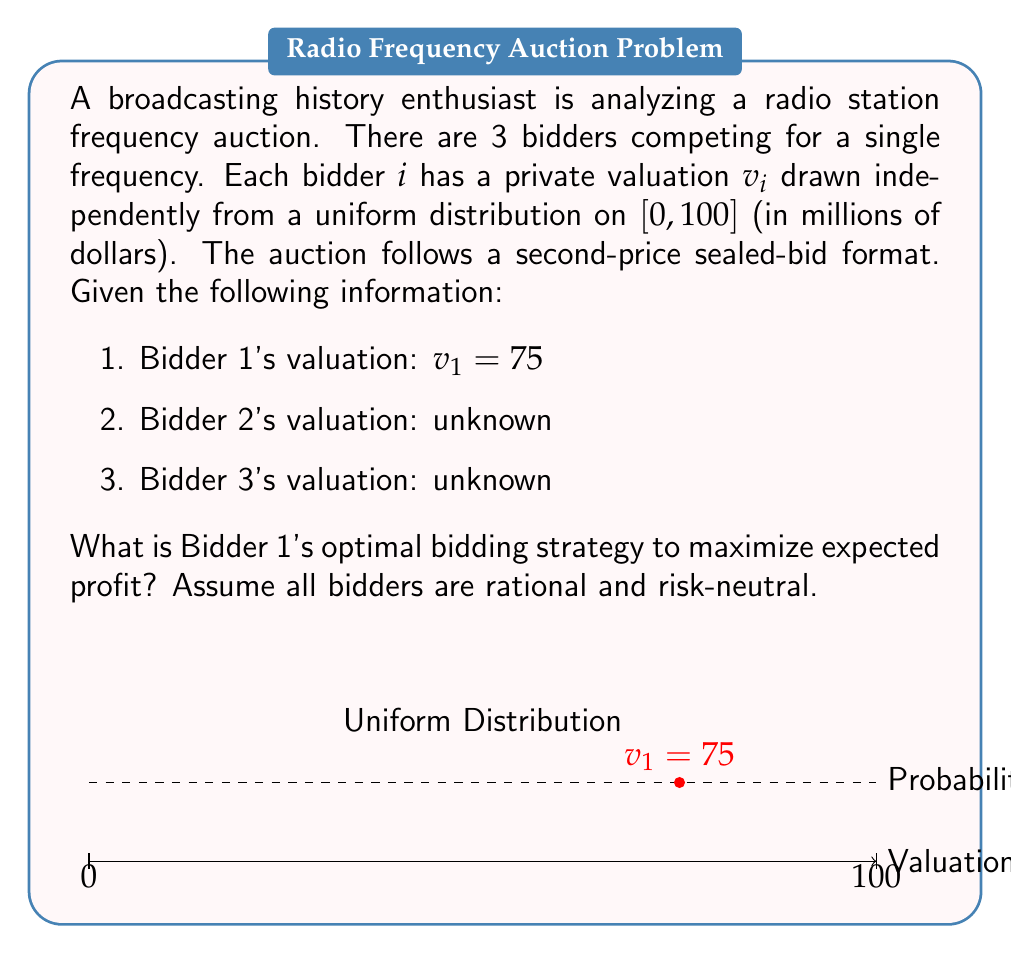Give your solution to this math problem. To solve this problem, we'll follow these steps:

1) In a second-price sealed-bid auction, the dominant strategy is to bid one's true valuation. This is because:

   a) Bidding above $v_1$ could result in winning but paying more than the valuation.
   b) Bidding below $v_1$ could result in losing when winning would have been profitable.

2) The optimal strategy is independent of other bidders' valuations or strategies.

3) Mathematically, we can prove this:

   Let $b_1$ be Bidder 1's bid and $p$ be the highest bid among other bidders.

   Expected profit: $E[\pi] = P(\text{win}) \cdot E[v_1 - p | \text{win}]$

   If $b_1 = v_1$:
   $$E[\pi] = P(p < v_1) \cdot E[v_1 - p | p < v_1] = \int_0^{v_1} (v_1 - p) \frac{1}{100} dp = \frac{v_1^2}{200}$$

   Any deviation from $b_1 = v_1$ will result in lower expected profit.

4) Therefore, Bidder 1's optimal strategy is to bid their true valuation: $75$ million dollars.

This strategy holds regardless of the number of bidders or their valuations, making it a dominant strategy in second-price auctions.
Answer: Bid $75$ million dollars. 